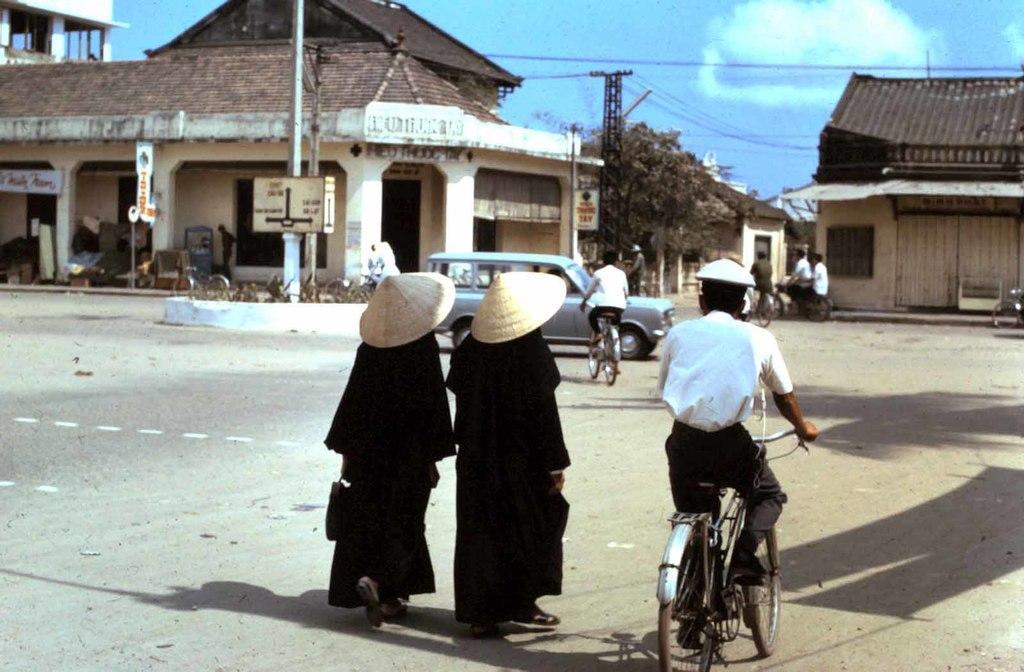How would you summarize this image in a sentence or two? The picture is on a road. Two peoples wearing black dress and hats are walking. On e man is riding cycle in front of him few people are also riding cycle , a car is passing by. In the background there are buildings, poles,trees. There are clouds on the sky. 